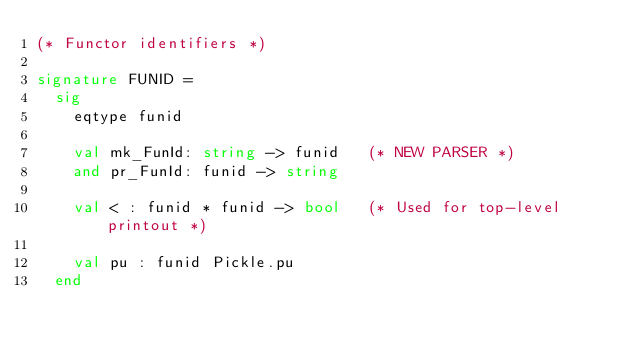Convert code to text. <code><loc_0><loc_0><loc_500><loc_500><_SML_>(* Functor identifiers *)

signature FUNID =
  sig
    eqtype funid

    val mk_FunId: string -> funid	(* NEW PARSER *)
    and pr_FunId: funid -> string

    val < : funid * funid -> bool	(* Used for top-level printout *)

    val pu : funid Pickle.pu
  end
</code> 